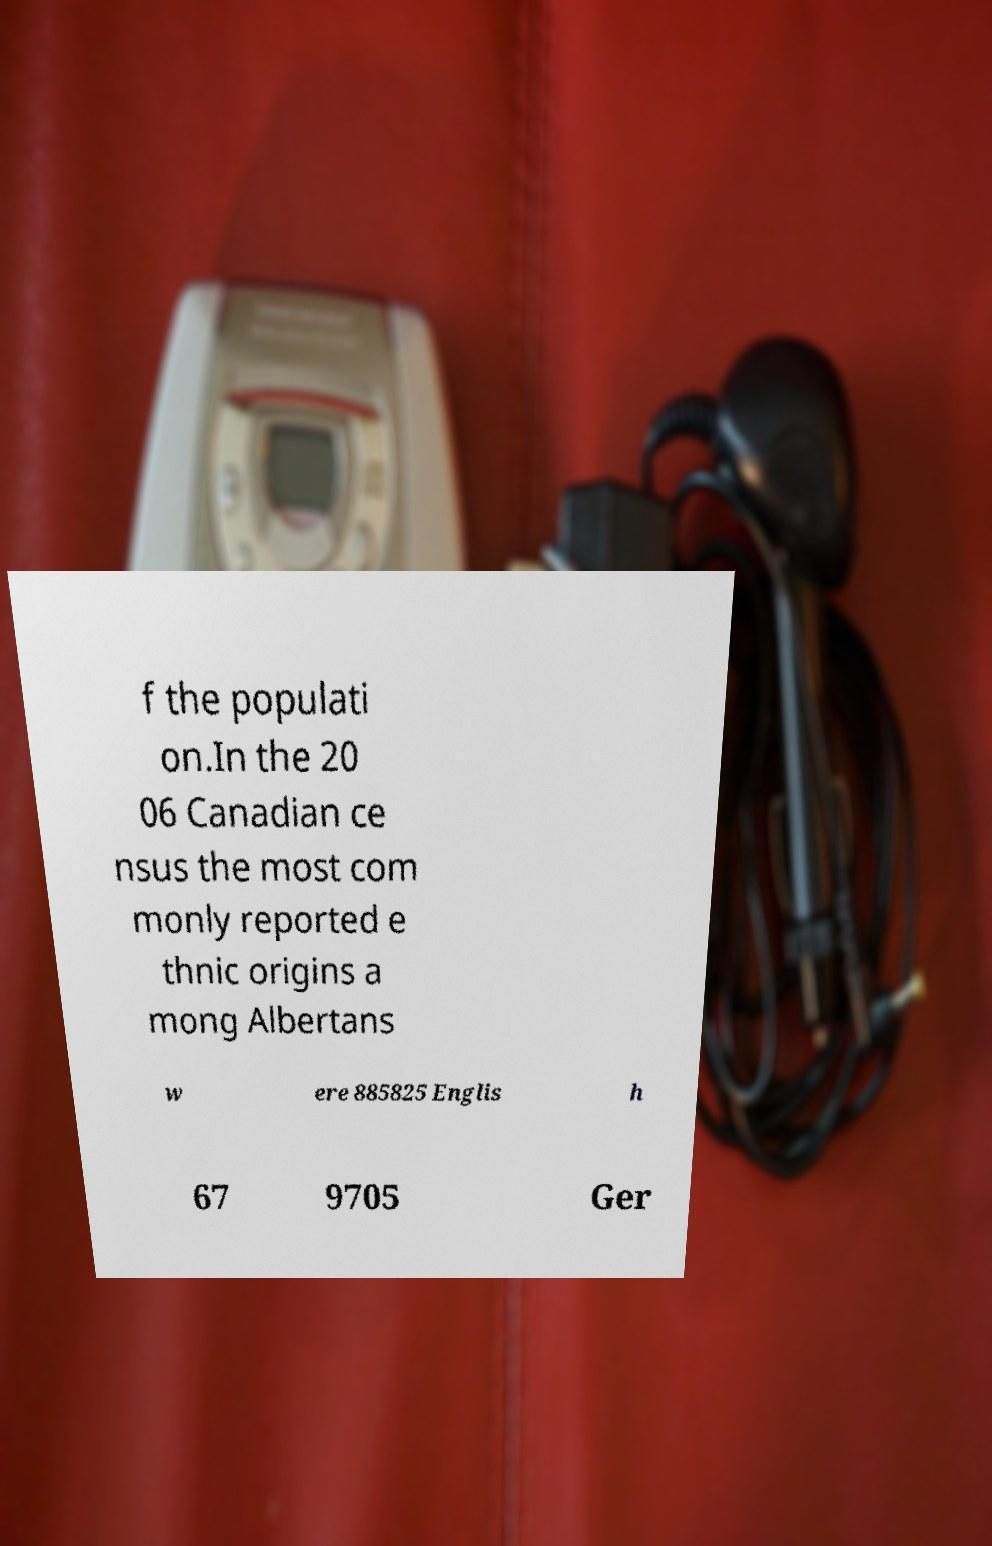I need the written content from this picture converted into text. Can you do that? f the populati on.In the 20 06 Canadian ce nsus the most com monly reported e thnic origins a mong Albertans w ere 885825 Englis h 67 9705 Ger 